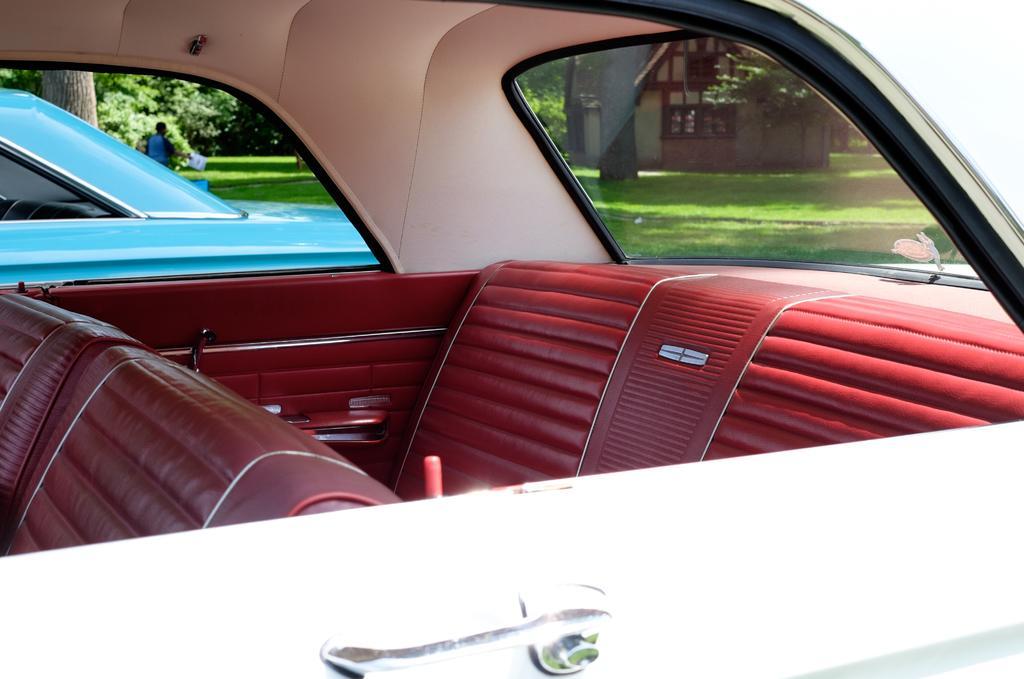Please provide a concise description of this image. In this image I can see two cars. Inside the car there are red color seats. In the background there are many trees and a house. On the ground, I can see the grass. On the left side there is a person. 